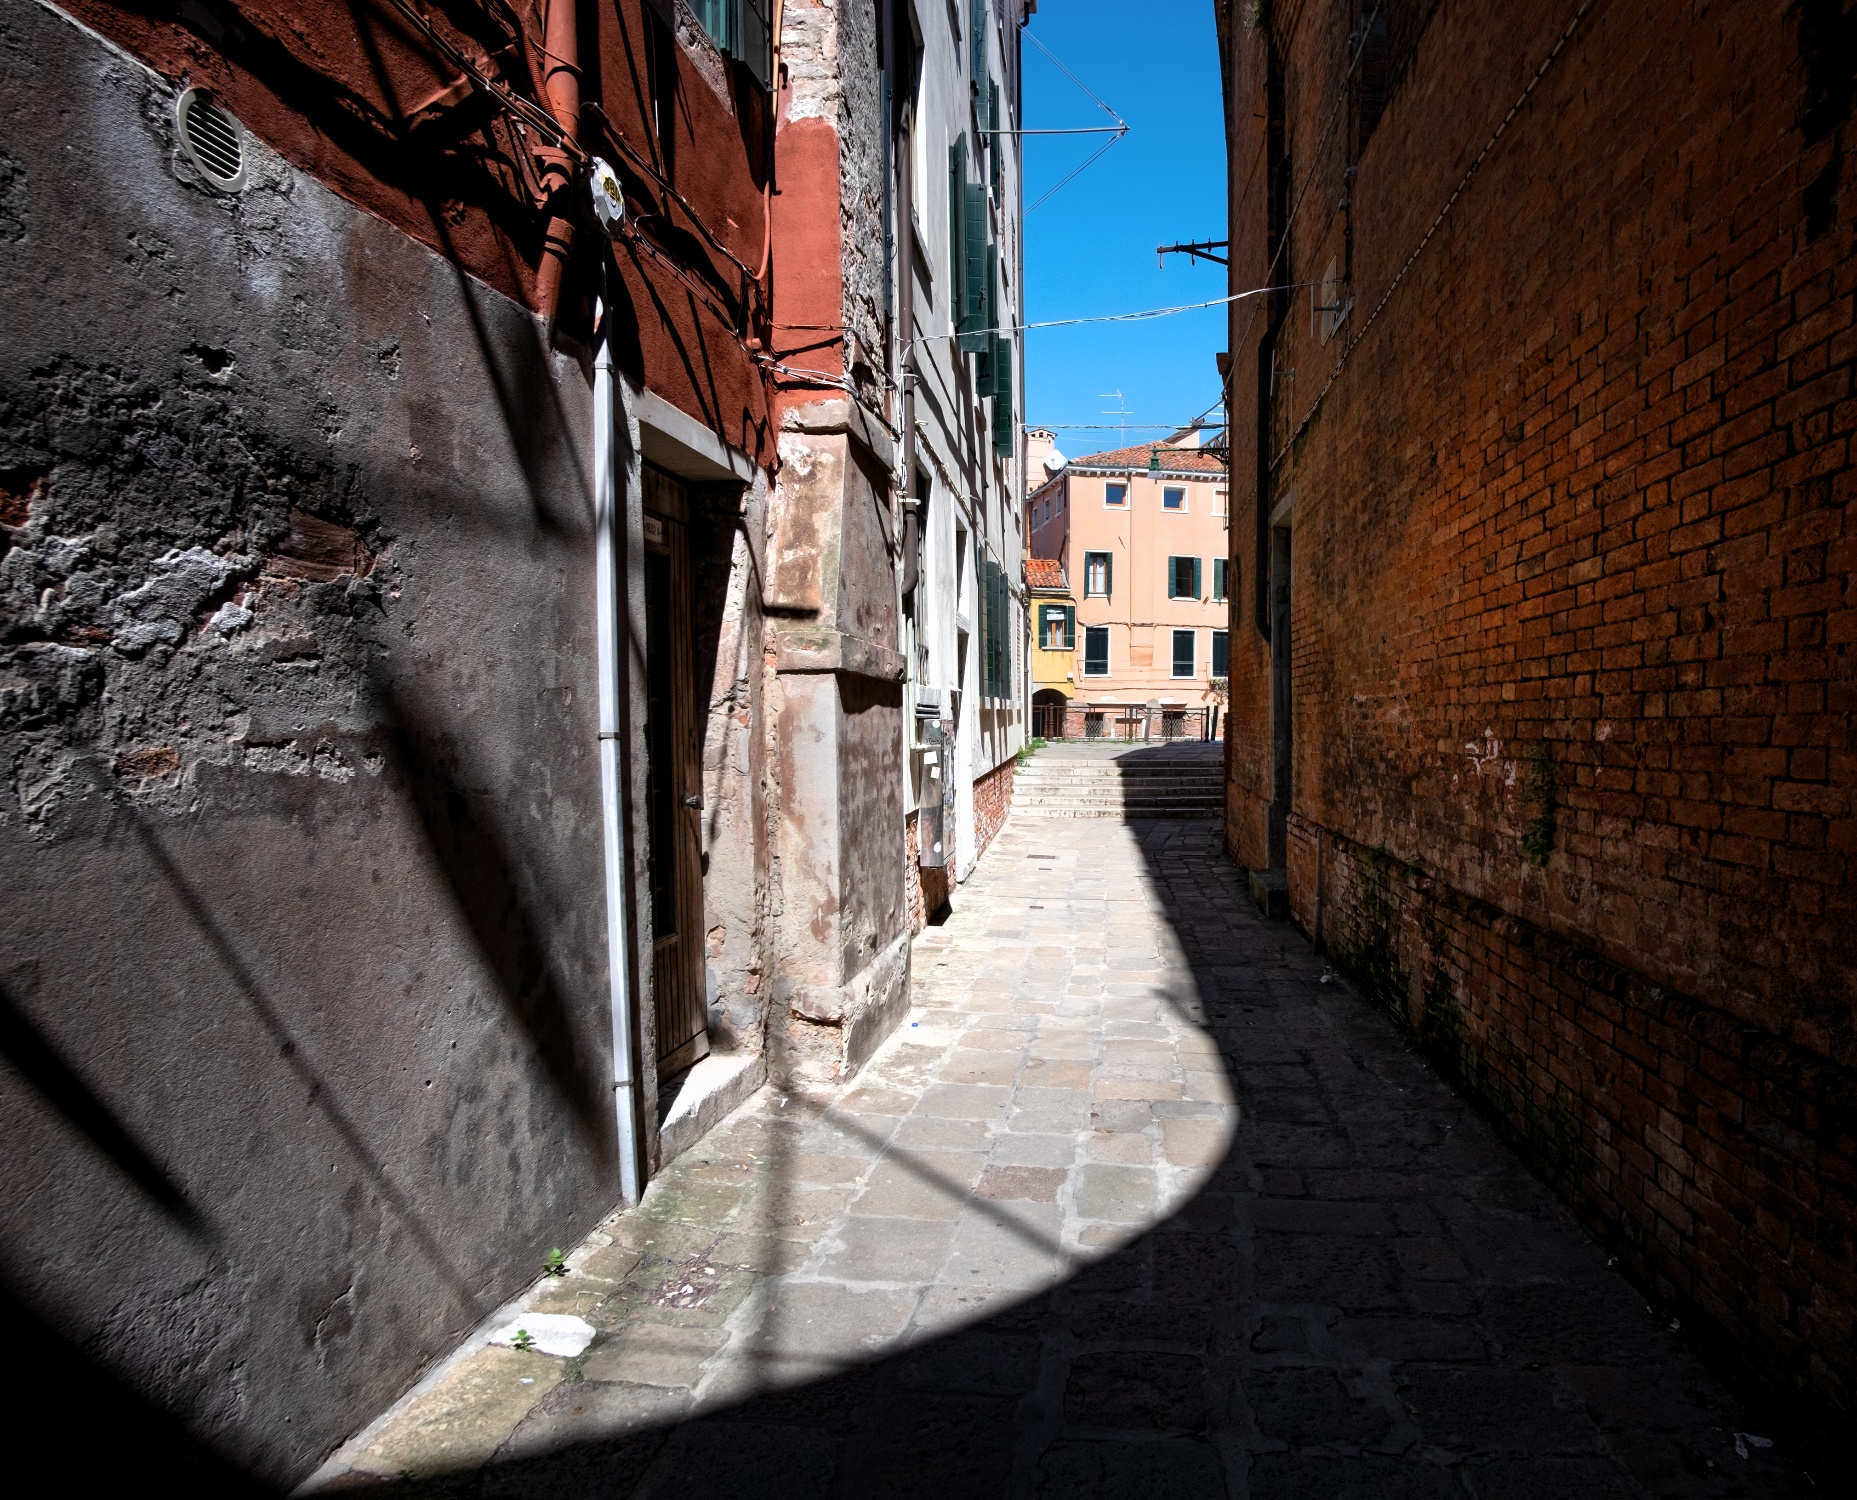Can you describe the main features of this image for me? The image depicts a charming, narrow alleyway in Venice, Italy, with its cobbled street flanked by timeworn brick buildings painted in shades of red and orange. The patina and texture of the old buildings tell a story of history and tradition, while a wispy clothesline strung above suggests a lingering daily life. The photograph is taken from a low-angle perspective, directing your gaze upwards towards a bright blue sky. Slivers of sunlight peek through the buildings, creating dramatic, elongated shadows that add a layer of mystique and highlight the architectural intricacies. It's a visually captivating snapshot of Venice’s uniquely atmospheric urban scenery. 